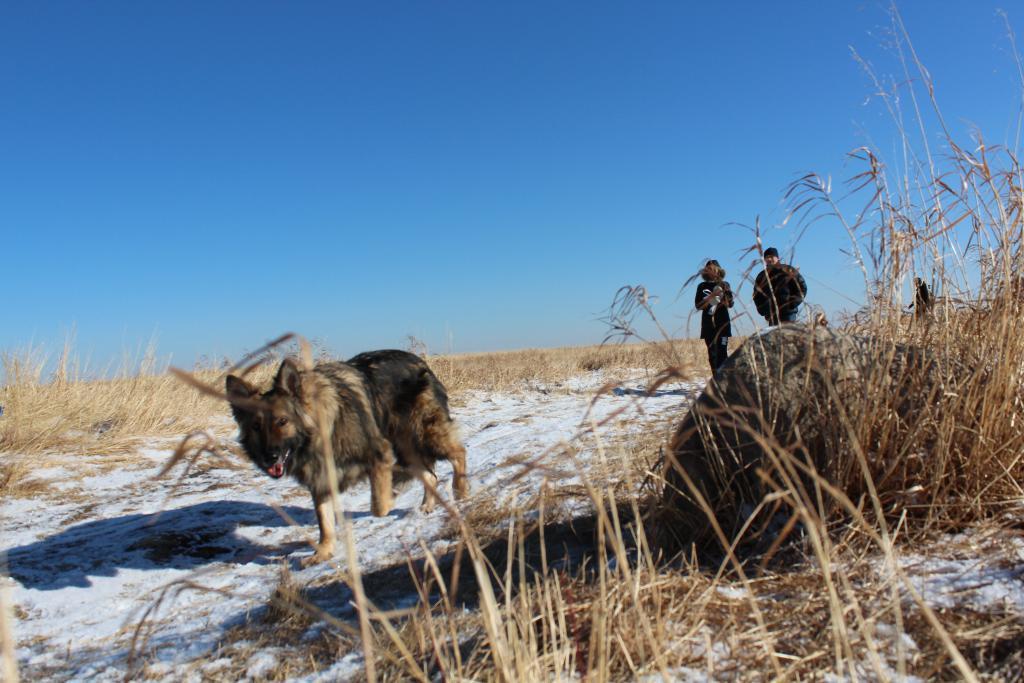How would you summarize this image in a sentence or two? To the right bottom of the image there is a dry grass on the ground. And in the middle of the image there is a wolf walking on the path. At the back of wolf there are two persons walking. In the background on the ground there is dry grass. And to the top of the image there is a blue color sky. 